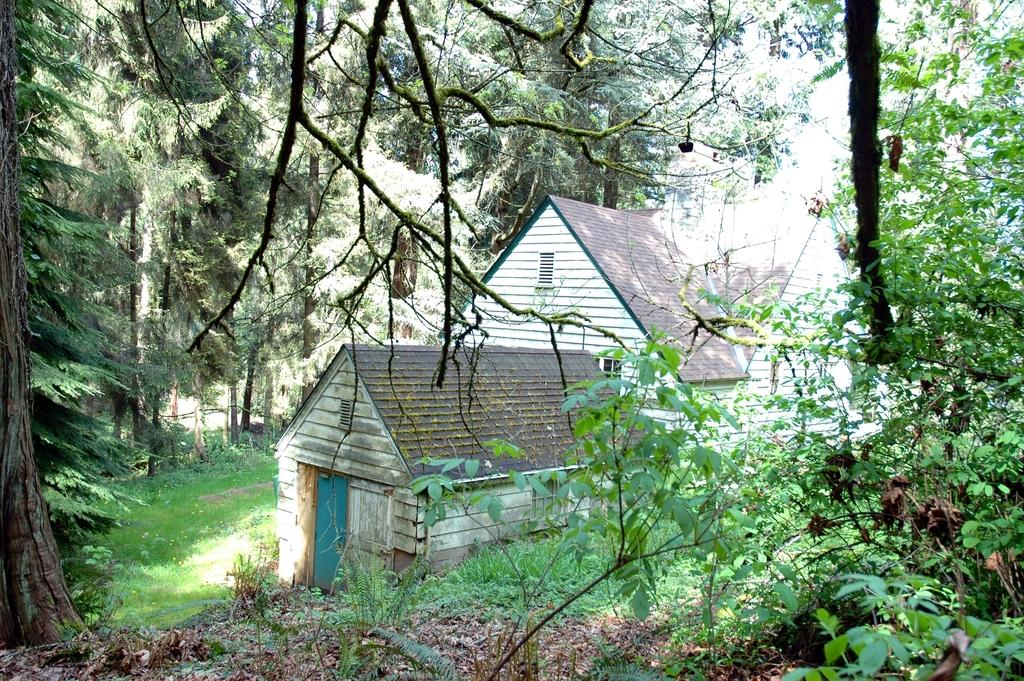What type of structure is visible in the image? There is a house in the image. Where are the trees located in the image? There are trees on both the left and right sides of the image. What type of vegetation is present at the bottom of the image? There is green grass and dried leaves at the bottom of the image. How does the ocean affect the temperature in the image? There is no ocean present in the image, so it cannot affect the temperature. What degree of difficulty is the house in the image? The image does not provide any information about the difficulty level of the house. 